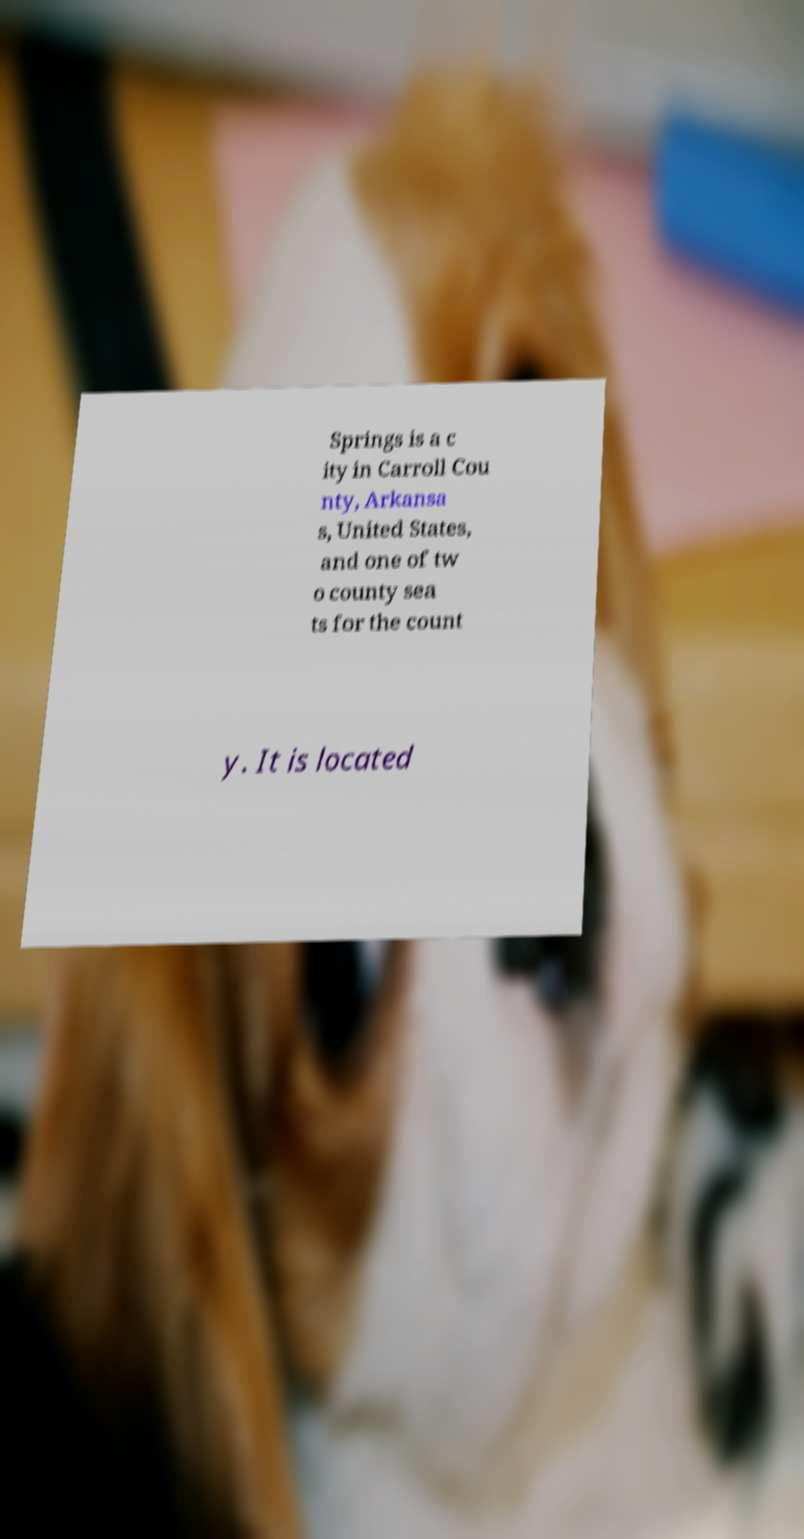Can you read and provide the text displayed in the image?This photo seems to have some interesting text. Can you extract and type it out for me? Springs is a c ity in Carroll Cou nty, Arkansa s, United States, and one of tw o county sea ts for the count y. It is located 